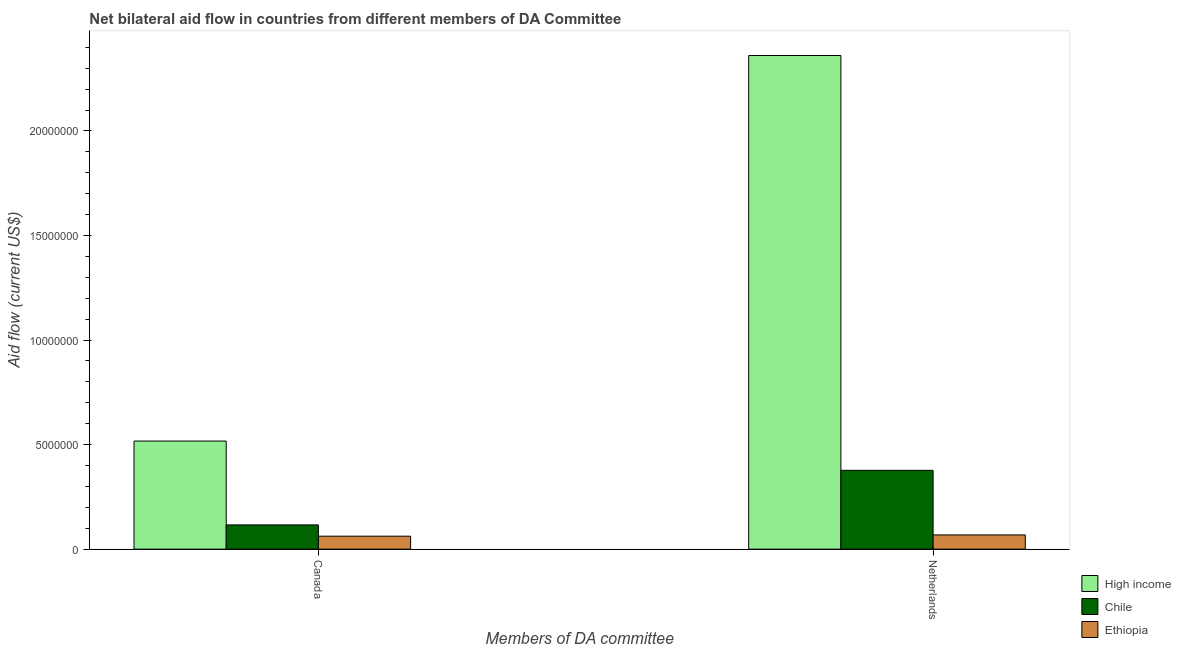Are the number of bars per tick equal to the number of legend labels?
Your answer should be very brief. Yes. Are the number of bars on each tick of the X-axis equal?
Offer a terse response. Yes. How many bars are there on the 1st tick from the right?
Offer a very short reply. 3. What is the label of the 1st group of bars from the left?
Your response must be concise. Canada. What is the amount of aid given by netherlands in Chile?
Your answer should be compact. 3.77e+06. Across all countries, what is the maximum amount of aid given by canada?
Make the answer very short. 5.17e+06. Across all countries, what is the minimum amount of aid given by canada?
Provide a short and direct response. 6.20e+05. In which country was the amount of aid given by netherlands minimum?
Give a very brief answer. Ethiopia. What is the total amount of aid given by canada in the graph?
Ensure brevity in your answer.  6.95e+06. What is the difference between the amount of aid given by canada in High income and that in Ethiopia?
Offer a very short reply. 4.55e+06. What is the difference between the amount of aid given by canada in Chile and the amount of aid given by netherlands in High income?
Give a very brief answer. -2.24e+07. What is the average amount of aid given by canada per country?
Your answer should be very brief. 2.32e+06. What is the difference between the amount of aid given by netherlands and amount of aid given by canada in High income?
Provide a succinct answer. 1.84e+07. In how many countries, is the amount of aid given by netherlands greater than 22000000 US$?
Provide a succinct answer. 1. What is the ratio of the amount of aid given by canada in Ethiopia to that in Chile?
Ensure brevity in your answer.  0.53. Is the amount of aid given by netherlands in Chile less than that in Ethiopia?
Offer a terse response. No. In how many countries, is the amount of aid given by netherlands greater than the average amount of aid given by netherlands taken over all countries?
Offer a very short reply. 1. What does the 2nd bar from the left in Netherlands represents?
Your response must be concise. Chile. What does the 2nd bar from the right in Netherlands represents?
Make the answer very short. Chile. How many bars are there?
Your answer should be compact. 6. Are all the bars in the graph horizontal?
Ensure brevity in your answer.  No. Does the graph contain any zero values?
Your answer should be compact. No. Does the graph contain grids?
Your answer should be very brief. No. Where does the legend appear in the graph?
Provide a short and direct response. Bottom right. What is the title of the graph?
Offer a terse response. Net bilateral aid flow in countries from different members of DA Committee. What is the label or title of the X-axis?
Your answer should be compact. Members of DA committee. What is the Aid flow (current US$) of High income in Canada?
Keep it short and to the point. 5.17e+06. What is the Aid flow (current US$) of Chile in Canada?
Give a very brief answer. 1.16e+06. What is the Aid flow (current US$) in Ethiopia in Canada?
Give a very brief answer. 6.20e+05. What is the Aid flow (current US$) in High income in Netherlands?
Offer a very short reply. 2.36e+07. What is the Aid flow (current US$) in Chile in Netherlands?
Make the answer very short. 3.77e+06. What is the Aid flow (current US$) in Ethiopia in Netherlands?
Keep it short and to the point. 6.80e+05. Across all Members of DA committee, what is the maximum Aid flow (current US$) of High income?
Your response must be concise. 2.36e+07. Across all Members of DA committee, what is the maximum Aid flow (current US$) of Chile?
Keep it short and to the point. 3.77e+06. Across all Members of DA committee, what is the maximum Aid flow (current US$) of Ethiopia?
Give a very brief answer. 6.80e+05. Across all Members of DA committee, what is the minimum Aid flow (current US$) in High income?
Your response must be concise. 5.17e+06. Across all Members of DA committee, what is the minimum Aid flow (current US$) in Chile?
Provide a succinct answer. 1.16e+06. Across all Members of DA committee, what is the minimum Aid flow (current US$) of Ethiopia?
Your response must be concise. 6.20e+05. What is the total Aid flow (current US$) of High income in the graph?
Make the answer very short. 2.88e+07. What is the total Aid flow (current US$) of Chile in the graph?
Your answer should be compact. 4.93e+06. What is the total Aid flow (current US$) of Ethiopia in the graph?
Provide a succinct answer. 1.30e+06. What is the difference between the Aid flow (current US$) in High income in Canada and that in Netherlands?
Provide a succinct answer. -1.84e+07. What is the difference between the Aid flow (current US$) in Chile in Canada and that in Netherlands?
Your answer should be very brief. -2.61e+06. What is the difference between the Aid flow (current US$) in Ethiopia in Canada and that in Netherlands?
Provide a succinct answer. -6.00e+04. What is the difference between the Aid flow (current US$) of High income in Canada and the Aid flow (current US$) of Chile in Netherlands?
Your answer should be compact. 1.40e+06. What is the difference between the Aid flow (current US$) of High income in Canada and the Aid flow (current US$) of Ethiopia in Netherlands?
Ensure brevity in your answer.  4.49e+06. What is the difference between the Aid flow (current US$) of Chile in Canada and the Aid flow (current US$) of Ethiopia in Netherlands?
Offer a terse response. 4.80e+05. What is the average Aid flow (current US$) of High income per Members of DA committee?
Give a very brief answer. 1.44e+07. What is the average Aid flow (current US$) in Chile per Members of DA committee?
Make the answer very short. 2.46e+06. What is the average Aid flow (current US$) of Ethiopia per Members of DA committee?
Give a very brief answer. 6.50e+05. What is the difference between the Aid flow (current US$) of High income and Aid flow (current US$) of Chile in Canada?
Make the answer very short. 4.01e+06. What is the difference between the Aid flow (current US$) of High income and Aid flow (current US$) of Ethiopia in Canada?
Ensure brevity in your answer.  4.55e+06. What is the difference between the Aid flow (current US$) in Chile and Aid flow (current US$) in Ethiopia in Canada?
Your answer should be compact. 5.40e+05. What is the difference between the Aid flow (current US$) in High income and Aid flow (current US$) in Chile in Netherlands?
Ensure brevity in your answer.  1.98e+07. What is the difference between the Aid flow (current US$) in High income and Aid flow (current US$) in Ethiopia in Netherlands?
Your response must be concise. 2.29e+07. What is the difference between the Aid flow (current US$) in Chile and Aid flow (current US$) in Ethiopia in Netherlands?
Keep it short and to the point. 3.09e+06. What is the ratio of the Aid flow (current US$) in High income in Canada to that in Netherlands?
Your answer should be very brief. 0.22. What is the ratio of the Aid flow (current US$) of Chile in Canada to that in Netherlands?
Offer a terse response. 0.31. What is the ratio of the Aid flow (current US$) of Ethiopia in Canada to that in Netherlands?
Your answer should be compact. 0.91. What is the difference between the highest and the second highest Aid flow (current US$) in High income?
Ensure brevity in your answer.  1.84e+07. What is the difference between the highest and the second highest Aid flow (current US$) in Chile?
Keep it short and to the point. 2.61e+06. What is the difference between the highest and the second highest Aid flow (current US$) in Ethiopia?
Your answer should be compact. 6.00e+04. What is the difference between the highest and the lowest Aid flow (current US$) of High income?
Offer a terse response. 1.84e+07. What is the difference between the highest and the lowest Aid flow (current US$) in Chile?
Ensure brevity in your answer.  2.61e+06. 